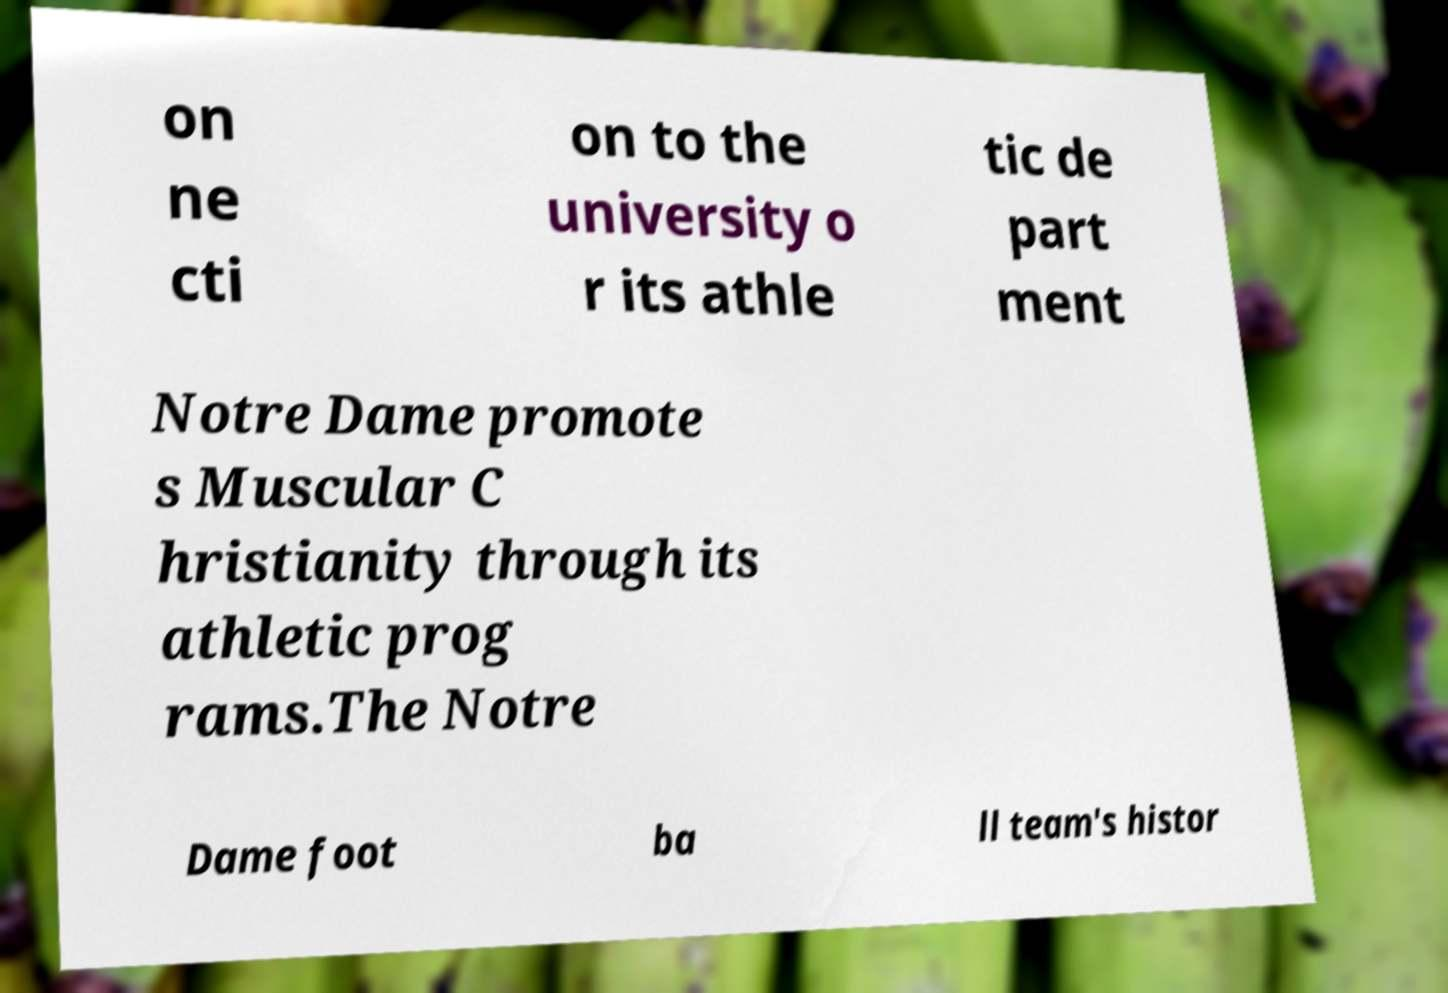What messages or text are displayed in this image? I need them in a readable, typed format. on ne cti on to the university o r its athle tic de part ment Notre Dame promote s Muscular C hristianity through its athletic prog rams.The Notre Dame foot ba ll team's histor 